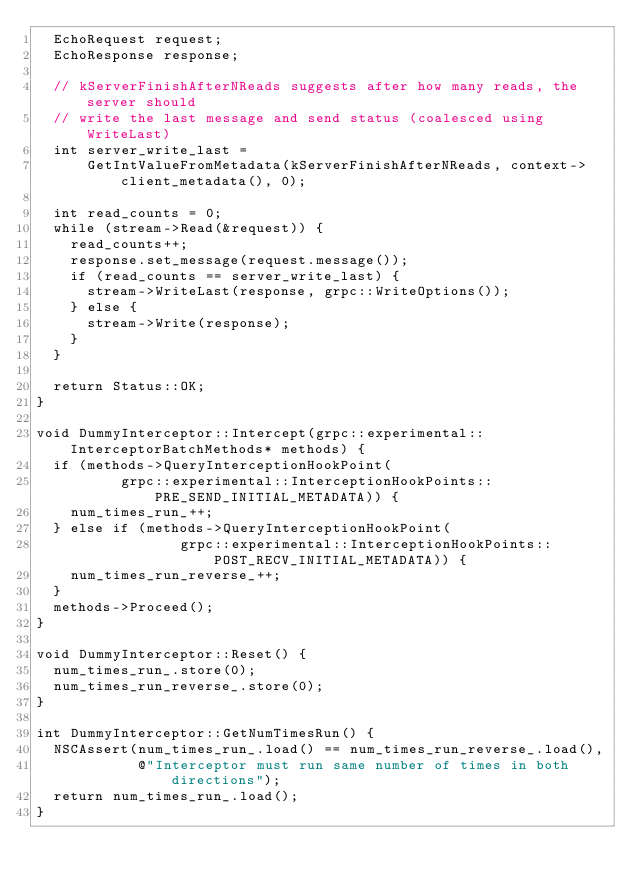Convert code to text. <code><loc_0><loc_0><loc_500><loc_500><_ObjectiveC_>  EchoRequest request;
  EchoResponse response;

  // kServerFinishAfterNReads suggests after how many reads, the server should
  // write the last message and send status (coalesced using WriteLast)
  int server_write_last =
      GetIntValueFromMetadata(kServerFinishAfterNReads, context->client_metadata(), 0);

  int read_counts = 0;
  while (stream->Read(&request)) {
    read_counts++;
    response.set_message(request.message());
    if (read_counts == server_write_last) {
      stream->WriteLast(response, grpc::WriteOptions());
    } else {
      stream->Write(response);
    }
  }

  return Status::OK;
}

void DummyInterceptor::Intercept(grpc::experimental::InterceptorBatchMethods* methods) {
  if (methods->QueryInterceptionHookPoint(
          grpc::experimental::InterceptionHookPoints::PRE_SEND_INITIAL_METADATA)) {
    num_times_run_++;
  } else if (methods->QueryInterceptionHookPoint(
                 grpc::experimental::InterceptionHookPoints::POST_RECV_INITIAL_METADATA)) {
    num_times_run_reverse_++;
  }
  methods->Proceed();
}

void DummyInterceptor::Reset() {
  num_times_run_.store(0);
  num_times_run_reverse_.store(0);
}

int DummyInterceptor::GetNumTimesRun() {
  NSCAssert(num_times_run_.load() == num_times_run_reverse_.load(),
            @"Interceptor must run same number of times in both directions");
  return num_times_run_.load();
}
</code> 